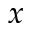<formula> <loc_0><loc_0><loc_500><loc_500>x</formula> 